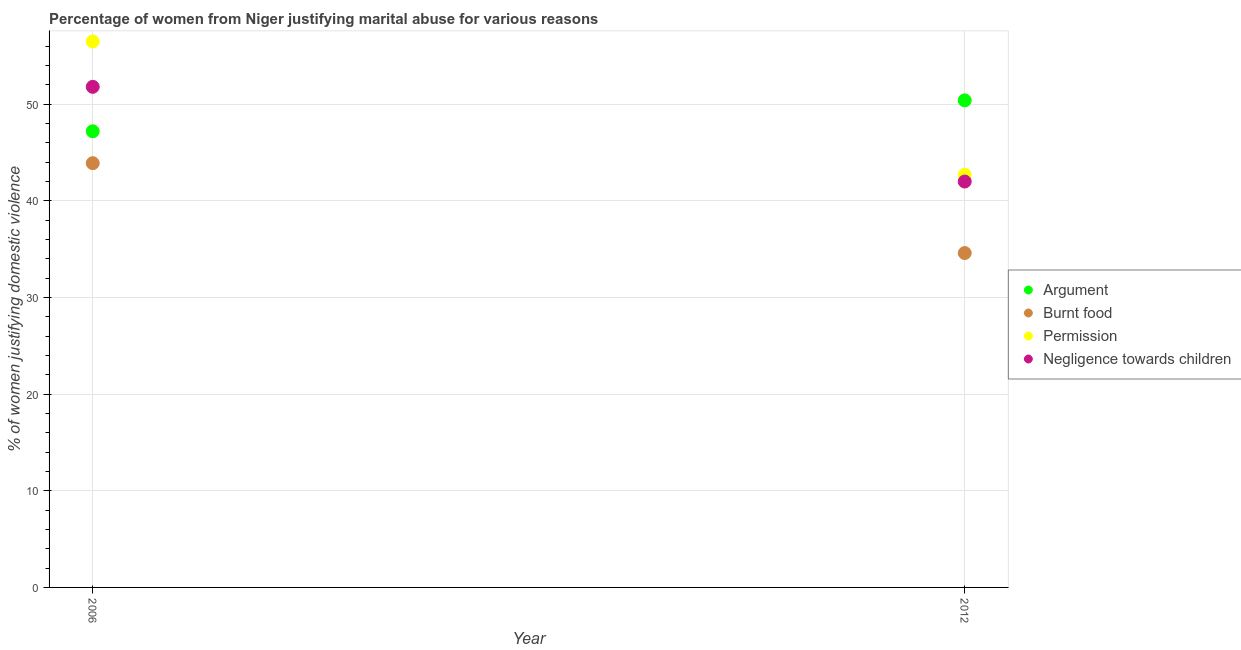How many different coloured dotlines are there?
Provide a succinct answer. 4. What is the percentage of women justifying abuse in the case of an argument in 2012?
Offer a terse response. 50.4. Across all years, what is the maximum percentage of women justifying abuse for going without permission?
Give a very brief answer. 56.5. Across all years, what is the minimum percentage of women justifying abuse in the case of an argument?
Your answer should be very brief. 47.2. In which year was the percentage of women justifying abuse for showing negligence towards children maximum?
Provide a short and direct response. 2006. In which year was the percentage of women justifying abuse for going without permission minimum?
Provide a succinct answer. 2012. What is the total percentage of women justifying abuse for burning food in the graph?
Offer a terse response. 78.5. What is the difference between the percentage of women justifying abuse for going without permission in 2006 and that in 2012?
Your answer should be compact. 13.8. What is the difference between the percentage of women justifying abuse in the case of an argument in 2006 and the percentage of women justifying abuse for showing negligence towards children in 2012?
Keep it short and to the point. 5.2. What is the average percentage of women justifying abuse for going without permission per year?
Give a very brief answer. 49.6. In the year 2012, what is the difference between the percentage of women justifying abuse for going without permission and percentage of women justifying abuse for burning food?
Provide a short and direct response. 8.1. What is the ratio of the percentage of women justifying abuse in the case of an argument in 2006 to that in 2012?
Make the answer very short. 0.94. Is it the case that in every year, the sum of the percentage of women justifying abuse in the case of an argument and percentage of women justifying abuse for burning food is greater than the percentage of women justifying abuse for going without permission?
Give a very brief answer. Yes. Is the percentage of women justifying abuse for burning food strictly greater than the percentage of women justifying abuse for showing negligence towards children over the years?
Your answer should be compact. No. Is the percentage of women justifying abuse for burning food strictly less than the percentage of women justifying abuse for going without permission over the years?
Provide a succinct answer. Yes. How many dotlines are there?
Offer a very short reply. 4. What is the difference between two consecutive major ticks on the Y-axis?
Make the answer very short. 10. Are the values on the major ticks of Y-axis written in scientific E-notation?
Provide a succinct answer. No. Does the graph contain any zero values?
Provide a short and direct response. No. Where does the legend appear in the graph?
Make the answer very short. Center right. How are the legend labels stacked?
Make the answer very short. Vertical. What is the title of the graph?
Your answer should be compact. Percentage of women from Niger justifying marital abuse for various reasons. Does "International Monetary Fund" appear as one of the legend labels in the graph?
Give a very brief answer. No. What is the label or title of the Y-axis?
Ensure brevity in your answer.  % of women justifying domestic violence. What is the % of women justifying domestic violence of Argument in 2006?
Make the answer very short. 47.2. What is the % of women justifying domestic violence of Burnt food in 2006?
Your response must be concise. 43.9. What is the % of women justifying domestic violence of Permission in 2006?
Provide a succinct answer. 56.5. What is the % of women justifying domestic violence of Negligence towards children in 2006?
Your answer should be very brief. 51.8. What is the % of women justifying domestic violence in Argument in 2012?
Offer a terse response. 50.4. What is the % of women justifying domestic violence of Burnt food in 2012?
Ensure brevity in your answer.  34.6. What is the % of women justifying domestic violence in Permission in 2012?
Make the answer very short. 42.7. What is the % of women justifying domestic violence in Negligence towards children in 2012?
Your answer should be compact. 42. Across all years, what is the maximum % of women justifying domestic violence in Argument?
Make the answer very short. 50.4. Across all years, what is the maximum % of women justifying domestic violence in Burnt food?
Offer a terse response. 43.9. Across all years, what is the maximum % of women justifying domestic violence of Permission?
Your answer should be compact. 56.5. Across all years, what is the maximum % of women justifying domestic violence of Negligence towards children?
Make the answer very short. 51.8. Across all years, what is the minimum % of women justifying domestic violence in Argument?
Ensure brevity in your answer.  47.2. Across all years, what is the minimum % of women justifying domestic violence in Burnt food?
Keep it short and to the point. 34.6. Across all years, what is the minimum % of women justifying domestic violence in Permission?
Provide a short and direct response. 42.7. What is the total % of women justifying domestic violence in Argument in the graph?
Provide a short and direct response. 97.6. What is the total % of women justifying domestic violence of Burnt food in the graph?
Provide a short and direct response. 78.5. What is the total % of women justifying domestic violence of Permission in the graph?
Your answer should be very brief. 99.2. What is the total % of women justifying domestic violence in Negligence towards children in the graph?
Offer a very short reply. 93.8. What is the difference between the % of women justifying domestic violence of Negligence towards children in 2006 and that in 2012?
Offer a terse response. 9.8. What is the difference between the % of women justifying domestic violence of Argument in 2006 and the % of women justifying domestic violence of Permission in 2012?
Make the answer very short. 4.5. What is the difference between the % of women justifying domestic violence in Burnt food in 2006 and the % of women justifying domestic violence in Permission in 2012?
Give a very brief answer. 1.2. What is the average % of women justifying domestic violence of Argument per year?
Offer a terse response. 48.8. What is the average % of women justifying domestic violence of Burnt food per year?
Give a very brief answer. 39.25. What is the average % of women justifying domestic violence of Permission per year?
Keep it short and to the point. 49.6. What is the average % of women justifying domestic violence of Negligence towards children per year?
Provide a succinct answer. 46.9. In the year 2006, what is the difference between the % of women justifying domestic violence of Argument and % of women justifying domestic violence of Burnt food?
Provide a succinct answer. 3.3. In the year 2006, what is the difference between the % of women justifying domestic violence of Argument and % of women justifying domestic violence of Permission?
Keep it short and to the point. -9.3. In the year 2006, what is the difference between the % of women justifying domestic violence in Argument and % of women justifying domestic violence in Negligence towards children?
Provide a succinct answer. -4.6. In the year 2006, what is the difference between the % of women justifying domestic violence of Permission and % of women justifying domestic violence of Negligence towards children?
Provide a succinct answer. 4.7. In the year 2012, what is the difference between the % of women justifying domestic violence in Argument and % of women justifying domestic violence in Burnt food?
Provide a succinct answer. 15.8. In the year 2012, what is the difference between the % of women justifying domestic violence of Argument and % of women justifying domestic violence of Negligence towards children?
Your response must be concise. 8.4. What is the ratio of the % of women justifying domestic violence in Argument in 2006 to that in 2012?
Your response must be concise. 0.94. What is the ratio of the % of women justifying domestic violence of Burnt food in 2006 to that in 2012?
Keep it short and to the point. 1.27. What is the ratio of the % of women justifying domestic violence of Permission in 2006 to that in 2012?
Offer a very short reply. 1.32. What is the ratio of the % of women justifying domestic violence of Negligence towards children in 2006 to that in 2012?
Keep it short and to the point. 1.23. What is the difference between the highest and the second highest % of women justifying domestic violence of Permission?
Your answer should be very brief. 13.8. What is the difference between the highest and the second highest % of women justifying domestic violence in Negligence towards children?
Make the answer very short. 9.8. What is the difference between the highest and the lowest % of women justifying domestic violence in Argument?
Provide a succinct answer. 3.2. What is the difference between the highest and the lowest % of women justifying domestic violence of Permission?
Your answer should be compact. 13.8. 